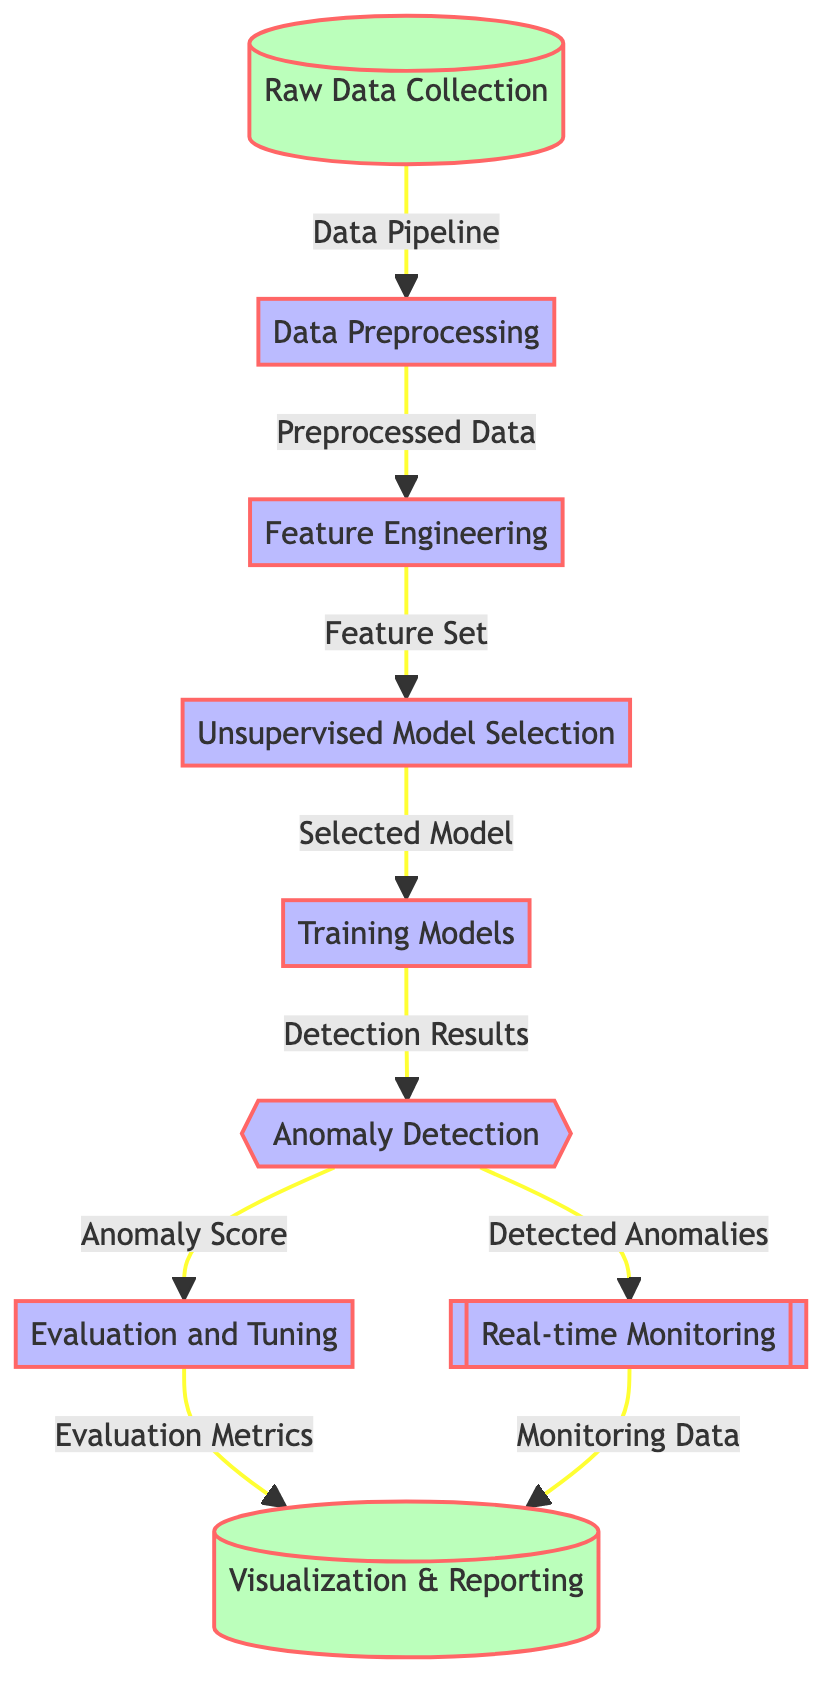What is the first step in the diagram? The first step is "Raw Data Collection," which is the starting point of the process for anomaly detection.
Answer: Raw Data Collection How many nodes are there in total? By counting each labeled box in the diagram, there are a total of nine nodes that represent various steps in the process.
Answer: Nine What connects "Data Preprocessing" and "Feature Engineering"? The connection is marked by the arrow indicating that the output from "Data Preprocessing" leads to "Feature Engineering," showing the sequential flow of data processing stages.
Answer: Preprocessed Data What type of model is used in the diagram? The diagram utilizes "Unsupervised Learning Techniques" as indicated under the stage of "Unsupervised Model Selection."
Answer: Unsupervised Learning Techniques What is produced after the "Training Models" step? Following the "Training Models" step, the output is labeled as "Detection Results," which indicates the outcome of the trained model's application.
Answer: Detection Results What happens to "Detected Anomalies" after they are identified? Once the "Detected Anomalies" are identified from the anomaly detection process, they are sent to the "Real-time Monitoring" node for ongoing observation, thus linking these two components in the flow.
Answer: Real-time Monitoring How are "Anomaly Scores" utilized in the process? The "Anomaly Scores" are used during the "Evaluation and Tuning" phase to assess the model's effectiveness and make necessary adjustments to improve detection accuracy.
Answer: Evaluation and Tuning What is the purpose of the "Visualization & Reporting" node? The "Visualization & Reporting" node serves as a means to present the findings, metrics, and results of the anomaly detection process in a comprehensible manner.
Answer: Visualization & Reporting What step comes after "Evaluation and Tuning"? The step following "Evaluation and Tuning" is "Visualization & Reporting," indicating that the results are shared and presented after evaluation processes are completed.
Answer: Visualization & Reporting 